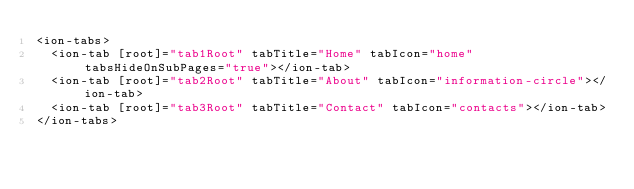Convert code to text. <code><loc_0><loc_0><loc_500><loc_500><_HTML_><ion-tabs>
  <ion-tab [root]="tab1Root" tabTitle="Home" tabIcon="home" tabsHideOnSubPages="true"></ion-tab>
  <ion-tab [root]="tab2Root" tabTitle="About" tabIcon="information-circle"></ion-tab>
  <ion-tab [root]="tab3Root" tabTitle="Contact" tabIcon="contacts"></ion-tab>
</ion-tabs>
</code> 